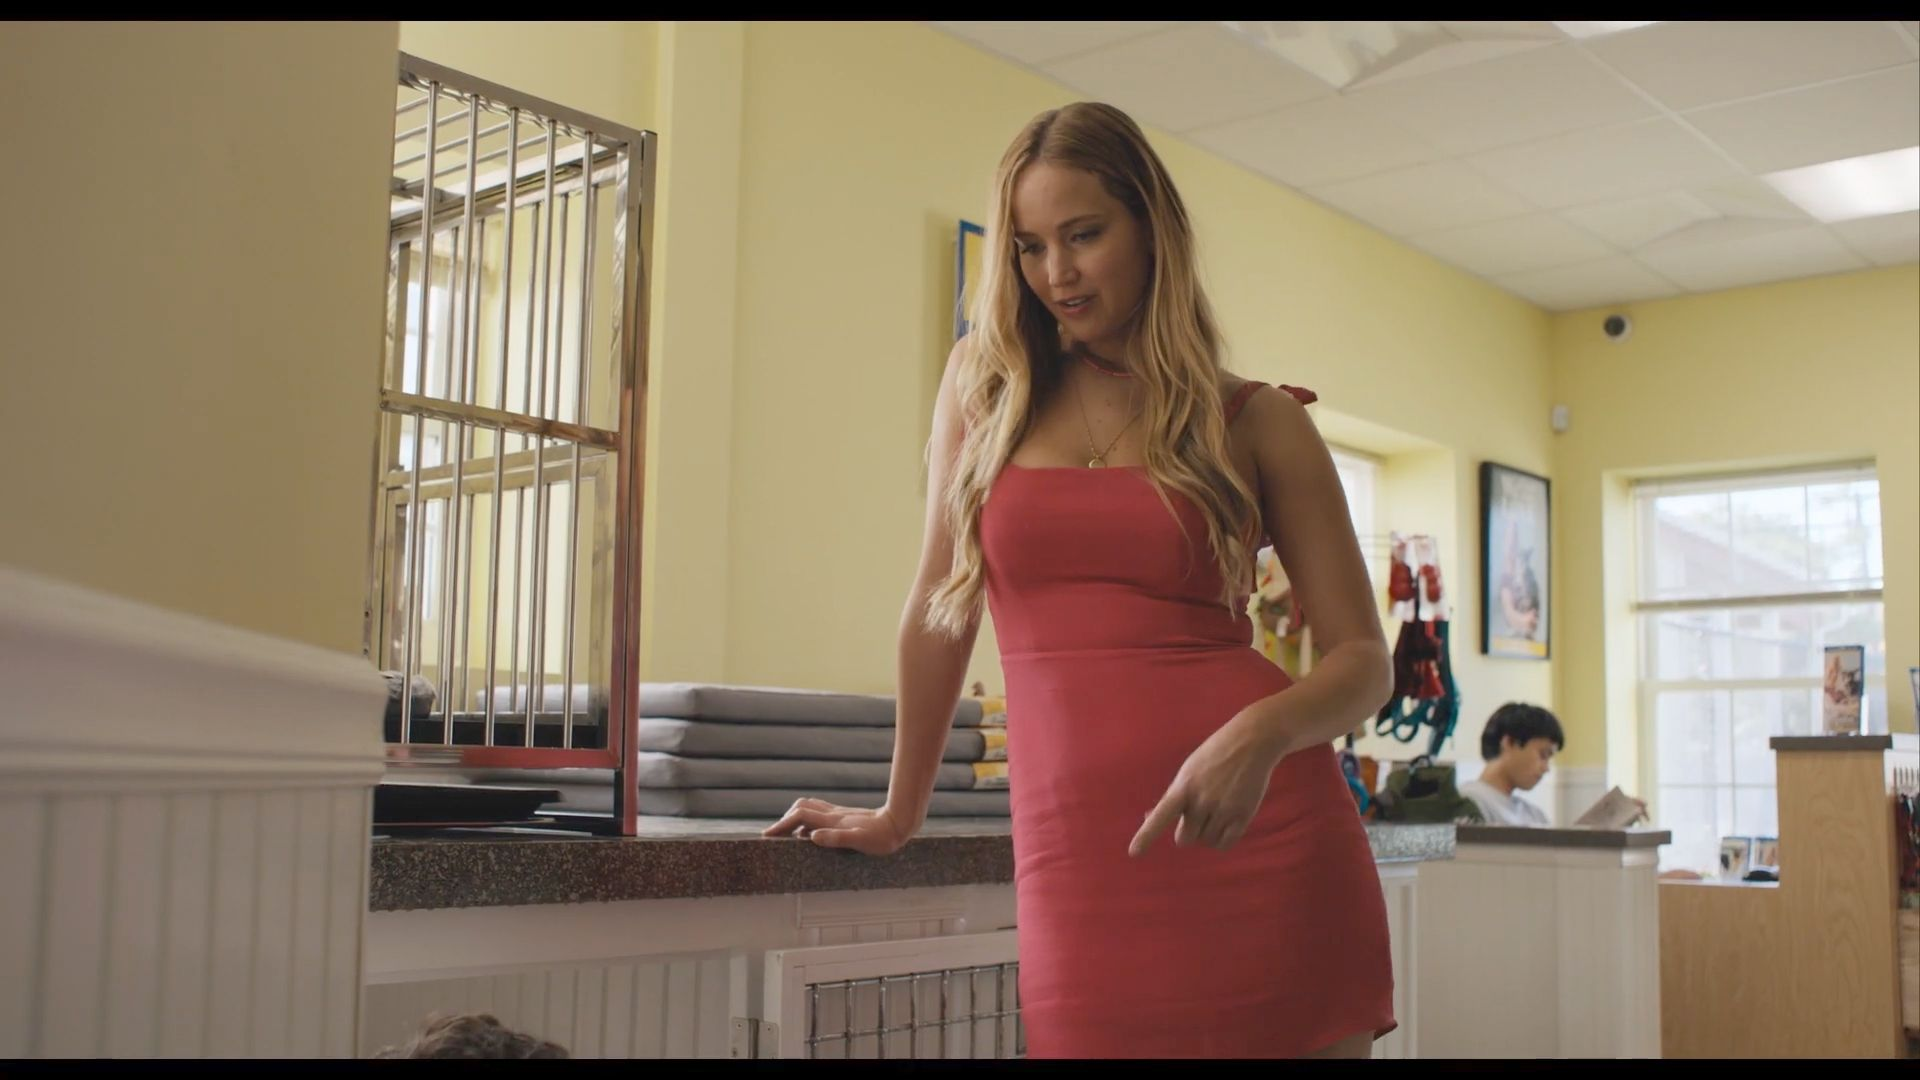What mood does the setting of this image evoke? The setting evokes a casual, yet intriguing mood. The brightness of the diner, combined with the vibrant color scheme of yellow walls and checkered floors, adds a cheerful tone. However, the barred window introduces a subtle hint of mystery or restriction, contrasting with the overall light atmosphere. 